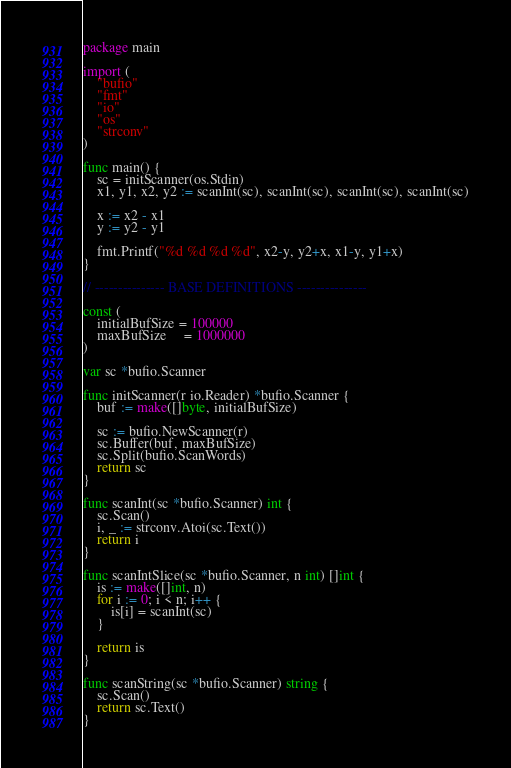Convert code to text. <code><loc_0><loc_0><loc_500><loc_500><_Go_>package main

import (
	"bufio"
	"fmt"
	"io"
	"os"
	"strconv"
)

func main() {
	sc = initScanner(os.Stdin)
	x1, y1, x2, y2 := scanInt(sc), scanInt(sc), scanInt(sc), scanInt(sc)

	x := x2 - x1
	y := y2 - y1

	fmt.Printf("%d %d %d %d", x2-y, y2+x, x1-y, y1+x)
}

// --------------- BASE DEFINITIONS ---------------

const (
	initialBufSize = 100000
	maxBufSize     = 1000000
)

var sc *bufio.Scanner

func initScanner(r io.Reader) *bufio.Scanner {
	buf := make([]byte, initialBufSize)

	sc := bufio.NewScanner(r)
	sc.Buffer(buf, maxBufSize)
	sc.Split(bufio.ScanWords)
	return sc
}

func scanInt(sc *bufio.Scanner) int {
	sc.Scan()
	i, _ := strconv.Atoi(sc.Text())
	return i
}

func scanIntSlice(sc *bufio.Scanner, n int) []int {
	is := make([]int, n)
	for i := 0; i < n; i++ {
		is[i] = scanInt(sc)
	}

	return is
}

func scanString(sc *bufio.Scanner) string {
	sc.Scan()
	return sc.Text()
}
</code> 